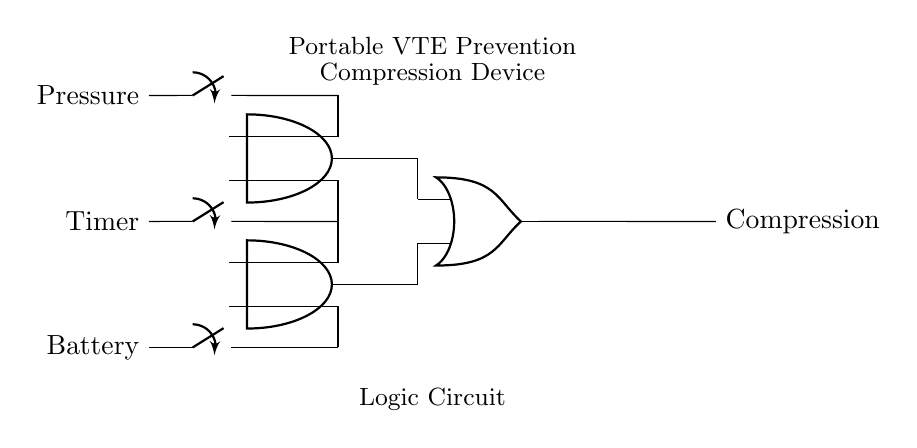What are the input components in this circuit? The input components are three switches labeled Pressure, Timer, and Battery. These switches represent the conditions under which the compression device operates.
Answer: Pressure, Timer, Battery How many AND gates are present in the circuit? There are two AND gates present in the circuit, which are used to combine the inputs from the switches. This is evident from the diagram showing two distinct AND gate symbols.
Answer: Two What is the function of the OR gate in this circuit? The OR gate functions to combine the outputs from both AND gates and produce a single output for the compression device. If either AND gate outputs a signal, the OR gate will activate the compression device.
Answer: Combine outputs What conditions activate the compression device? The compression device is activated if either the output from the first AND gate (which requires Pressure and Timer) or the second AND gate (which requires Timer and Battery) sends a signal.
Answer: Pressure and Timer, Timer and Battery What is the output of the circuit? The output of the circuit is Compression, indicating that it produces a compression effect based on certain input conditions being met. This is the result of the logic gates processing the inputs.
Answer: Compression Which components are connected to the second AND gate? The second AND gate is connected to the Timer switch and the Battery switch. It indicates that both input conditions must be satisfied to produce an output from this gate.
Answer: Timer, Battery 